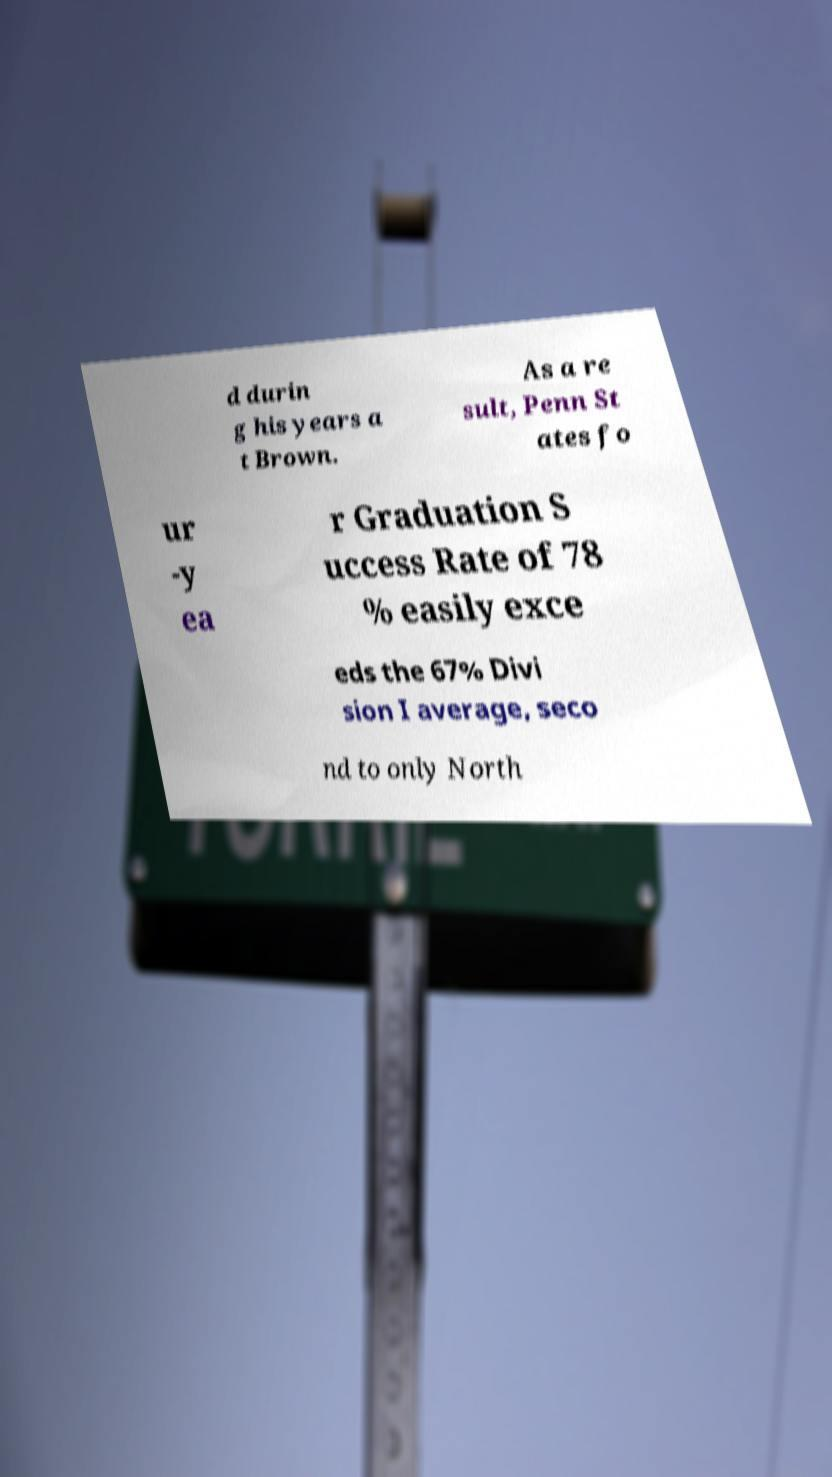What messages or text are displayed in this image? I need them in a readable, typed format. d durin g his years a t Brown. As a re sult, Penn St ates fo ur -y ea r Graduation S uccess Rate of 78 % easily exce eds the 67% Divi sion I average, seco nd to only North 